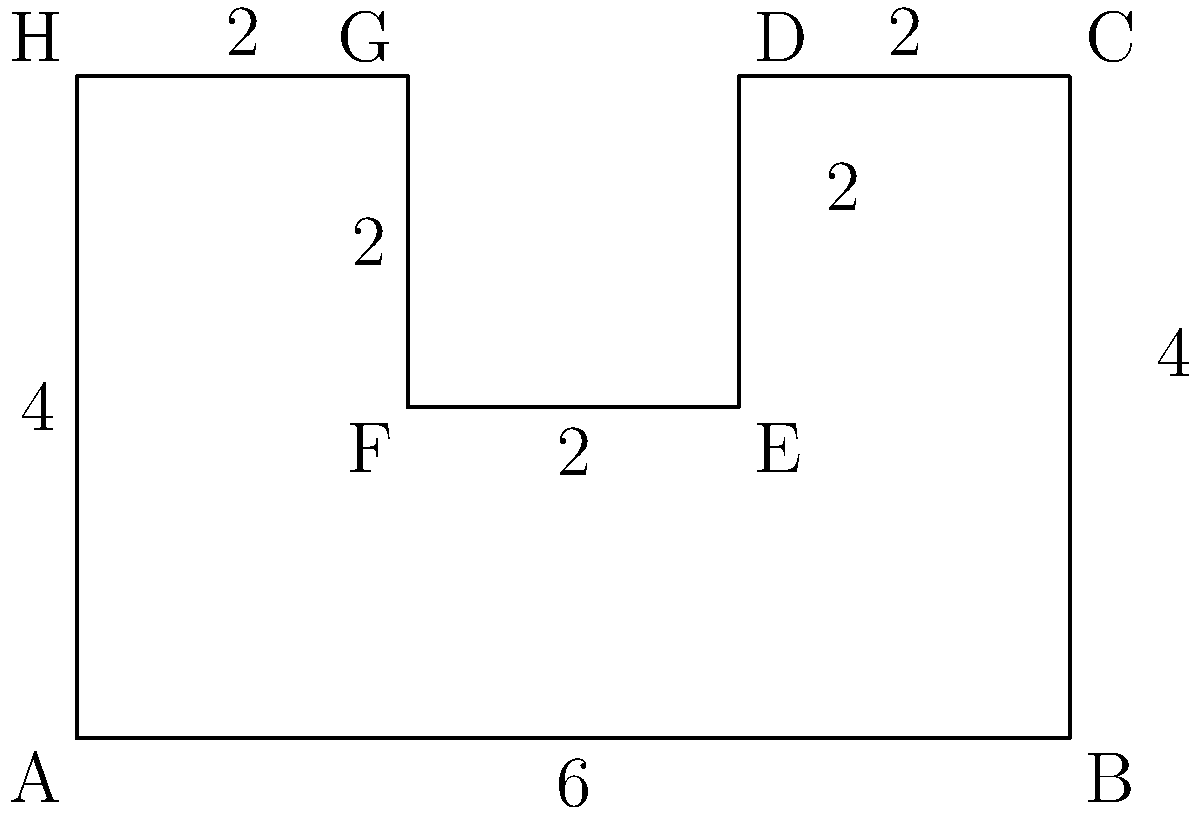A climate policy has led to changes in land use, represented by the polygon ABCDEFGH. If each unit in the figure represents 1000 hectares, calculate the total area affected by this policy change. How might this information be used to assess the economic impact of the climate policy? To solve this problem, we need to follow these steps:

1) The polygon can be divided into rectangles for easier calculation:
   - Rectangle ABCH: $6 \times 4 = 24$ square units
   - Rectangle DEFG: $2 \times 2 = 4$ square units

2) The total area is the difference between these rectangles:
   $\text{Total Area} = 24 - 4 = 20$ square units

3) Since each unit represents 1000 hectares:
   $\text{Total Area in hectares} = 20 \times 1000 = 20,000$ hectares

4) Economic impact assessment:
   - This information can be used to estimate the economic value of the land use change.
   - For example, if the previous land use generated $X per hectare, and the new use generates $Y per hectare, the net economic impact would be $(Y-X) \times 20,000$.
   - This could include changes in agricultural output, carbon sequestration, or other ecosystem services.
   - The area affected also indicates the scale of the policy impact, which can be used in cost-benefit analyses of the climate policy.
   - It can help in designing appropriate economic incentives or compensation schemes for landowners affected by the policy.
Answer: 20,000 hectares 